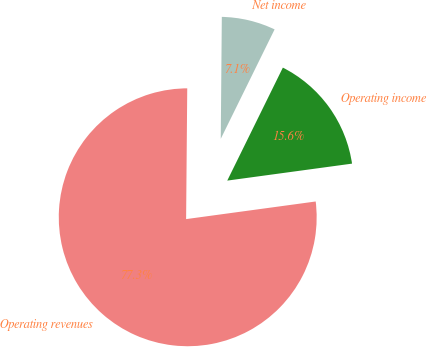<chart> <loc_0><loc_0><loc_500><loc_500><pie_chart><fcel>Operating revenues<fcel>Operating income<fcel>Net income<nl><fcel>77.29%<fcel>15.57%<fcel>7.14%<nl></chart> 